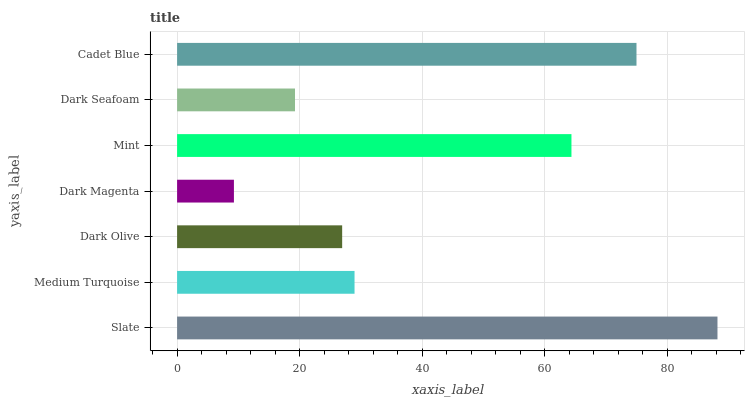Is Dark Magenta the minimum?
Answer yes or no. Yes. Is Slate the maximum?
Answer yes or no. Yes. Is Medium Turquoise the minimum?
Answer yes or no. No. Is Medium Turquoise the maximum?
Answer yes or no. No. Is Slate greater than Medium Turquoise?
Answer yes or no. Yes. Is Medium Turquoise less than Slate?
Answer yes or no. Yes. Is Medium Turquoise greater than Slate?
Answer yes or no. No. Is Slate less than Medium Turquoise?
Answer yes or no. No. Is Medium Turquoise the high median?
Answer yes or no. Yes. Is Medium Turquoise the low median?
Answer yes or no. Yes. Is Cadet Blue the high median?
Answer yes or no. No. Is Dark Magenta the low median?
Answer yes or no. No. 